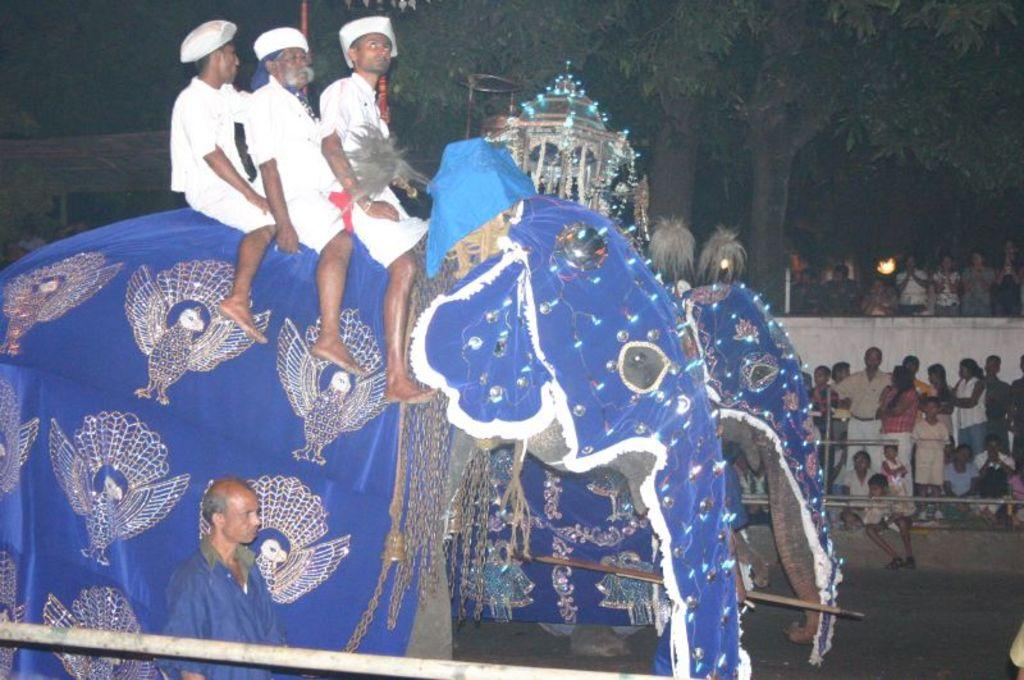What is the main subject of the image? The main subject of the image is three men sitting on an elephant. Can you describe the background of the image? There is a tree visible in the background, and there are other persons standing and additional persons in the background. What type of rail can be seen in the image? There is no rail present in the image. Is there a sidewalk visible in the image? There is no sidewalk present in the image. 